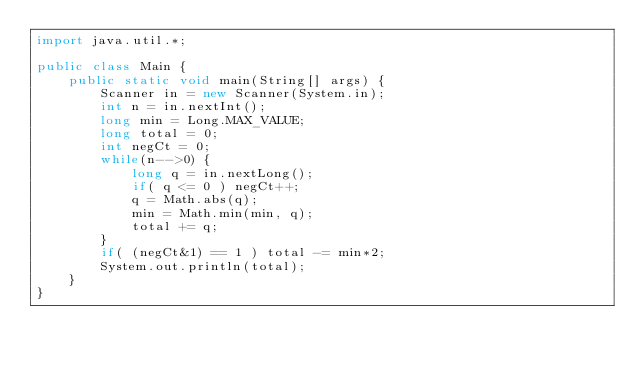Convert code to text. <code><loc_0><loc_0><loc_500><loc_500><_Java_>import java.util.*;

public class Main {
    public static void main(String[] args) {
        Scanner in = new Scanner(System.in);
        int n = in.nextInt();
        long min = Long.MAX_VALUE;
        long total = 0;
        int negCt = 0;
        while(n-->0) {
            long q = in.nextLong();
            if( q <= 0 ) negCt++;
            q = Math.abs(q);
            min = Math.min(min, q);
            total += q;
        }
        if( (negCt&1) == 1 ) total -= min*2;
        System.out.println(total);
    }
}</code> 